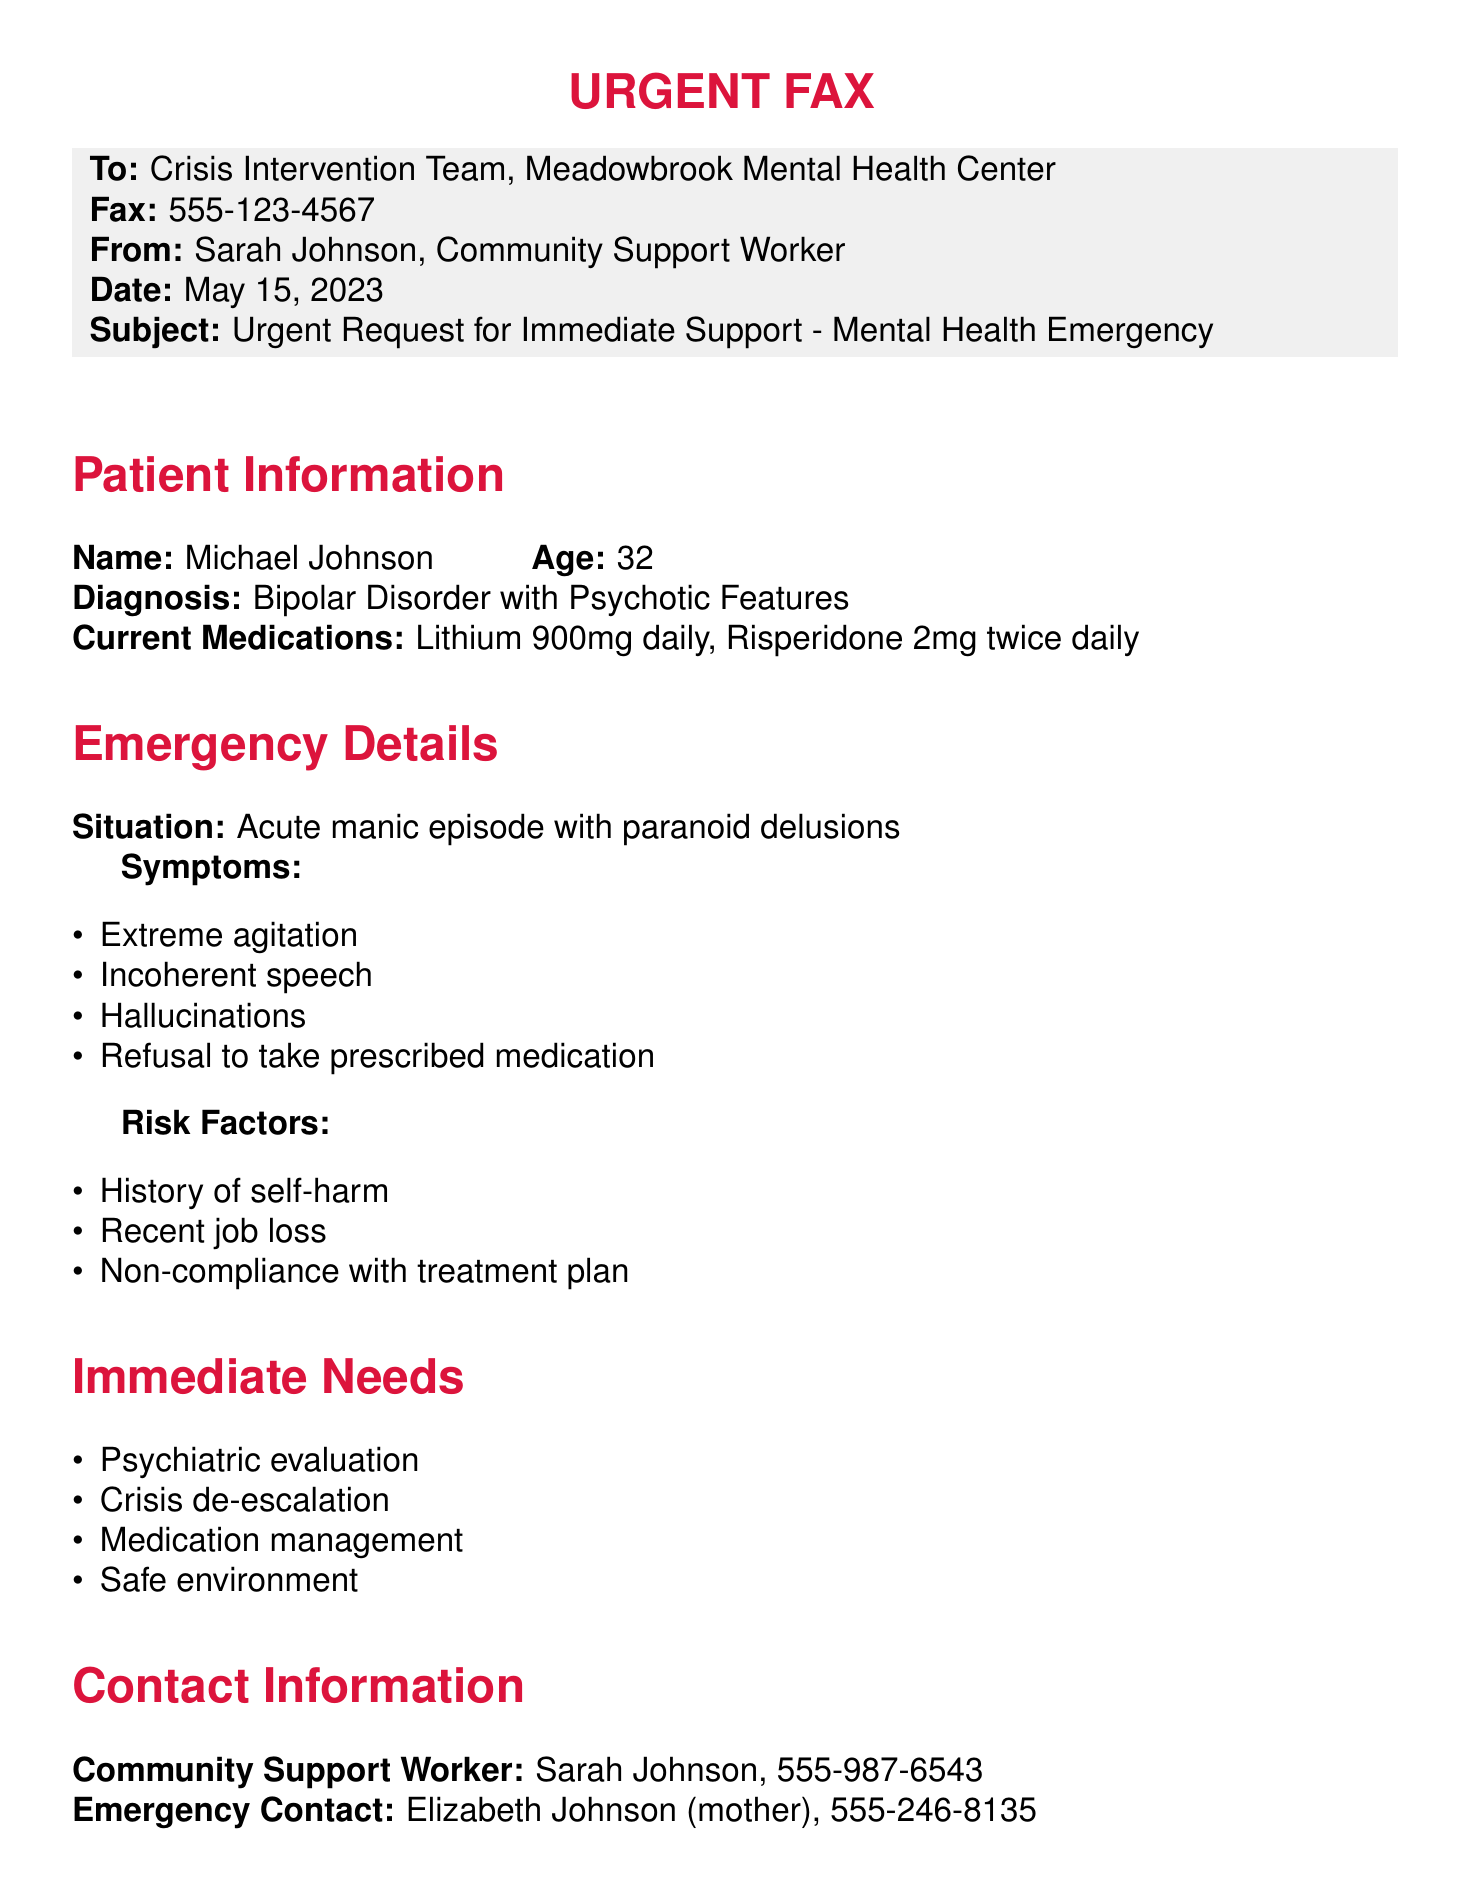What is the patient's name? The patient's name is mentioned in the Patient Information section of the document.
Answer: Michael Johnson What is the age of the patient? The age of the patient is specified alongside the patient's name in the document.
Answer: 32 What is the primary diagnosis of the patient? The diagnosis of the patient is listed in the Patient Information section.
Answer: Bipolar Disorder with Psychotic Features What symptom involves confusion and inability to communicate clearly? This symptom is explicitly mentioned in the Symptoms subsection.
Answer: Incoherent speech How many medications is the patient currently taking? The Current Medications section lists two medications prescribed to the patient.
Answer: Two What is one of the immediate needs listed in the document? Immediate needs are outlined in the Immediate Needs section.
Answer: Psychiatric evaluation Who is the emergency contact for the patient? The emergency contact is specified in the Contact Information section.
Answer: Elizabeth Johnson What type of episode is Michael having during this emergency? The document describes the current mental health situation in the Emergency Details section.
Answer: Acute manic episode What is the fax number to the Crisis Intervention Team? The fax number is presented at the beginning of the document.
Answer: 555-123-4567 